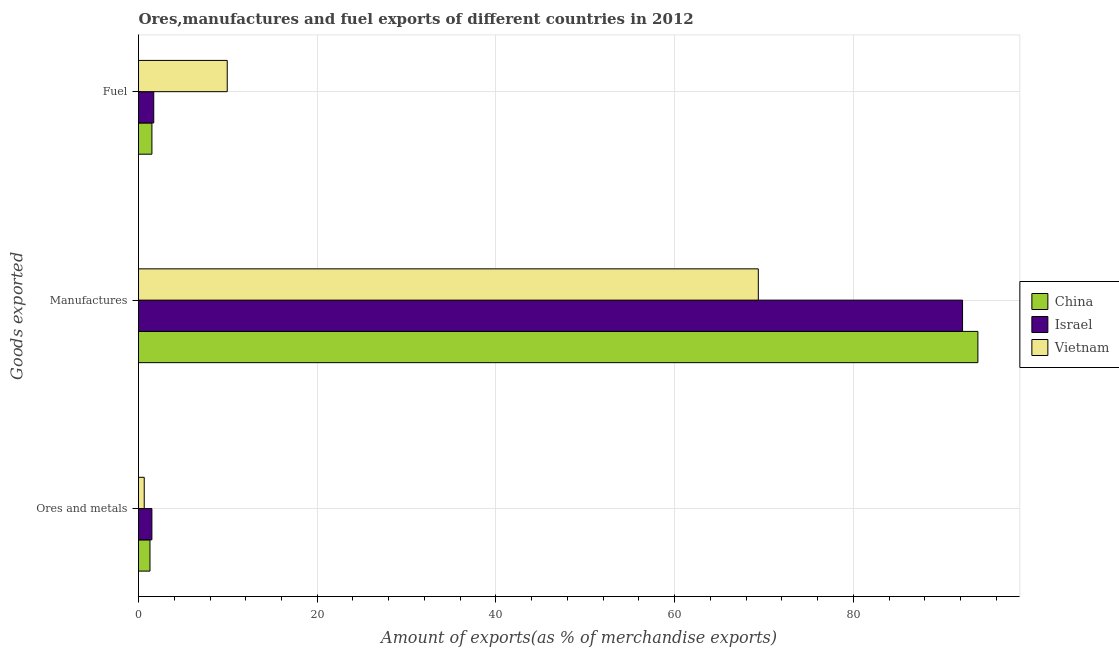Are the number of bars per tick equal to the number of legend labels?
Keep it short and to the point. Yes. How many bars are there on the 1st tick from the top?
Offer a terse response. 3. How many bars are there on the 3rd tick from the bottom?
Keep it short and to the point. 3. What is the label of the 3rd group of bars from the top?
Your answer should be very brief. Ores and metals. What is the percentage of fuel exports in Israel?
Provide a short and direct response. 1.7. Across all countries, what is the maximum percentage of manufactures exports?
Provide a succinct answer. 93.93. Across all countries, what is the minimum percentage of fuel exports?
Give a very brief answer. 1.5. In which country was the percentage of manufactures exports maximum?
Make the answer very short. China. What is the total percentage of fuel exports in the graph?
Provide a succinct answer. 13.14. What is the difference between the percentage of manufactures exports in Israel and that in Vietnam?
Give a very brief answer. 22.86. What is the difference between the percentage of fuel exports in Vietnam and the percentage of ores and metals exports in China?
Make the answer very short. 8.65. What is the average percentage of manufactures exports per country?
Offer a very short reply. 85.17. What is the difference between the percentage of ores and metals exports and percentage of manufactures exports in China?
Ensure brevity in your answer.  -92.65. In how many countries, is the percentage of ores and metals exports greater than 12 %?
Offer a terse response. 0. What is the ratio of the percentage of fuel exports in China to that in Israel?
Your response must be concise. 0.88. What is the difference between the highest and the second highest percentage of ores and metals exports?
Offer a terse response. 0.21. What is the difference between the highest and the lowest percentage of fuel exports?
Offer a terse response. 8.43. In how many countries, is the percentage of fuel exports greater than the average percentage of fuel exports taken over all countries?
Offer a terse response. 1. How many countries are there in the graph?
Your answer should be very brief. 3. Does the graph contain any zero values?
Provide a short and direct response. No. Where does the legend appear in the graph?
Offer a very short reply. Center right. How many legend labels are there?
Keep it short and to the point. 3. How are the legend labels stacked?
Your answer should be compact. Vertical. What is the title of the graph?
Offer a terse response. Ores,manufactures and fuel exports of different countries in 2012. Does "Turkmenistan" appear as one of the legend labels in the graph?
Ensure brevity in your answer.  No. What is the label or title of the X-axis?
Provide a succinct answer. Amount of exports(as % of merchandise exports). What is the label or title of the Y-axis?
Your response must be concise. Goods exported. What is the Amount of exports(as % of merchandise exports) in China in Ores and metals?
Ensure brevity in your answer.  1.28. What is the Amount of exports(as % of merchandise exports) of Israel in Ores and metals?
Your answer should be compact. 1.5. What is the Amount of exports(as % of merchandise exports) of Vietnam in Ores and metals?
Give a very brief answer. 0.64. What is the Amount of exports(as % of merchandise exports) of China in Manufactures?
Give a very brief answer. 93.93. What is the Amount of exports(as % of merchandise exports) of Israel in Manufactures?
Provide a succinct answer. 92.22. What is the Amount of exports(as % of merchandise exports) of Vietnam in Manufactures?
Ensure brevity in your answer.  69.36. What is the Amount of exports(as % of merchandise exports) in China in Fuel?
Offer a very short reply. 1.5. What is the Amount of exports(as % of merchandise exports) in Israel in Fuel?
Keep it short and to the point. 1.7. What is the Amount of exports(as % of merchandise exports) in Vietnam in Fuel?
Ensure brevity in your answer.  9.93. Across all Goods exported, what is the maximum Amount of exports(as % of merchandise exports) in China?
Ensure brevity in your answer.  93.93. Across all Goods exported, what is the maximum Amount of exports(as % of merchandise exports) of Israel?
Keep it short and to the point. 92.22. Across all Goods exported, what is the maximum Amount of exports(as % of merchandise exports) in Vietnam?
Make the answer very short. 69.36. Across all Goods exported, what is the minimum Amount of exports(as % of merchandise exports) of China?
Give a very brief answer. 1.28. Across all Goods exported, what is the minimum Amount of exports(as % of merchandise exports) in Israel?
Offer a very short reply. 1.5. Across all Goods exported, what is the minimum Amount of exports(as % of merchandise exports) of Vietnam?
Provide a succinct answer. 0.64. What is the total Amount of exports(as % of merchandise exports) of China in the graph?
Keep it short and to the point. 96.72. What is the total Amount of exports(as % of merchandise exports) of Israel in the graph?
Your answer should be compact. 95.42. What is the total Amount of exports(as % of merchandise exports) in Vietnam in the graph?
Your answer should be compact. 79.93. What is the difference between the Amount of exports(as % of merchandise exports) in China in Ores and metals and that in Manufactures?
Offer a terse response. -92.65. What is the difference between the Amount of exports(as % of merchandise exports) in Israel in Ores and metals and that in Manufactures?
Offer a terse response. -90.72. What is the difference between the Amount of exports(as % of merchandise exports) of Vietnam in Ores and metals and that in Manufactures?
Keep it short and to the point. -68.72. What is the difference between the Amount of exports(as % of merchandise exports) in China in Ores and metals and that in Fuel?
Give a very brief answer. -0.22. What is the difference between the Amount of exports(as % of merchandise exports) in Israel in Ores and metals and that in Fuel?
Offer a terse response. -0.21. What is the difference between the Amount of exports(as % of merchandise exports) of Vietnam in Ores and metals and that in Fuel?
Offer a terse response. -9.29. What is the difference between the Amount of exports(as % of merchandise exports) of China in Manufactures and that in Fuel?
Offer a terse response. 92.43. What is the difference between the Amount of exports(as % of merchandise exports) in Israel in Manufactures and that in Fuel?
Offer a terse response. 90.51. What is the difference between the Amount of exports(as % of merchandise exports) in Vietnam in Manufactures and that in Fuel?
Offer a terse response. 59.43. What is the difference between the Amount of exports(as % of merchandise exports) of China in Ores and metals and the Amount of exports(as % of merchandise exports) of Israel in Manufactures?
Ensure brevity in your answer.  -90.93. What is the difference between the Amount of exports(as % of merchandise exports) in China in Ores and metals and the Amount of exports(as % of merchandise exports) in Vietnam in Manufactures?
Provide a succinct answer. -68.08. What is the difference between the Amount of exports(as % of merchandise exports) in Israel in Ores and metals and the Amount of exports(as % of merchandise exports) in Vietnam in Manufactures?
Provide a short and direct response. -67.86. What is the difference between the Amount of exports(as % of merchandise exports) of China in Ores and metals and the Amount of exports(as % of merchandise exports) of Israel in Fuel?
Keep it short and to the point. -0.42. What is the difference between the Amount of exports(as % of merchandise exports) in China in Ores and metals and the Amount of exports(as % of merchandise exports) in Vietnam in Fuel?
Provide a succinct answer. -8.65. What is the difference between the Amount of exports(as % of merchandise exports) in Israel in Ores and metals and the Amount of exports(as % of merchandise exports) in Vietnam in Fuel?
Offer a very short reply. -8.43. What is the difference between the Amount of exports(as % of merchandise exports) in China in Manufactures and the Amount of exports(as % of merchandise exports) in Israel in Fuel?
Give a very brief answer. 92.23. What is the difference between the Amount of exports(as % of merchandise exports) in China in Manufactures and the Amount of exports(as % of merchandise exports) in Vietnam in Fuel?
Ensure brevity in your answer.  84. What is the difference between the Amount of exports(as % of merchandise exports) in Israel in Manufactures and the Amount of exports(as % of merchandise exports) in Vietnam in Fuel?
Keep it short and to the point. 82.29. What is the average Amount of exports(as % of merchandise exports) in China per Goods exported?
Ensure brevity in your answer.  32.24. What is the average Amount of exports(as % of merchandise exports) of Israel per Goods exported?
Offer a very short reply. 31.81. What is the average Amount of exports(as % of merchandise exports) of Vietnam per Goods exported?
Your answer should be compact. 26.64. What is the difference between the Amount of exports(as % of merchandise exports) of China and Amount of exports(as % of merchandise exports) of Israel in Ores and metals?
Your answer should be compact. -0.21. What is the difference between the Amount of exports(as % of merchandise exports) in China and Amount of exports(as % of merchandise exports) in Vietnam in Ores and metals?
Ensure brevity in your answer.  0.64. What is the difference between the Amount of exports(as % of merchandise exports) in Israel and Amount of exports(as % of merchandise exports) in Vietnam in Ores and metals?
Give a very brief answer. 0.86. What is the difference between the Amount of exports(as % of merchandise exports) in China and Amount of exports(as % of merchandise exports) in Israel in Manufactures?
Provide a succinct answer. 1.72. What is the difference between the Amount of exports(as % of merchandise exports) in China and Amount of exports(as % of merchandise exports) in Vietnam in Manufactures?
Give a very brief answer. 24.57. What is the difference between the Amount of exports(as % of merchandise exports) of Israel and Amount of exports(as % of merchandise exports) of Vietnam in Manufactures?
Your answer should be compact. 22.86. What is the difference between the Amount of exports(as % of merchandise exports) in China and Amount of exports(as % of merchandise exports) in Israel in Fuel?
Ensure brevity in your answer.  -0.2. What is the difference between the Amount of exports(as % of merchandise exports) of China and Amount of exports(as % of merchandise exports) of Vietnam in Fuel?
Your answer should be very brief. -8.43. What is the difference between the Amount of exports(as % of merchandise exports) in Israel and Amount of exports(as % of merchandise exports) in Vietnam in Fuel?
Give a very brief answer. -8.23. What is the ratio of the Amount of exports(as % of merchandise exports) of China in Ores and metals to that in Manufactures?
Provide a short and direct response. 0.01. What is the ratio of the Amount of exports(as % of merchandise exports) of Israel in Ores and metals to that in Manufactures?
Make the answer very short. 0.02. What is the ratio of the Amount of exports(as % of merchandise exports) of Vietnam in Ores and metals to that in Manufactures?
Offer a terse response. 0.01. What is the ratio of the Amount of exports(as % of merchandise exports) of China in Ores and metals to that in Fuel?
Provide a short and direct response. 0.86. What is the ratio of the Amount of exports(as % of merchandise exports) of Israel in Ores and metals to that in Fuel?
Make the answer very short. 0.88. What is the ratio of the Amount of exports(as % of merchandise exports) of Vietnam in Ores and metals to that in Fuel?
Your answer should be very brief. 0.06. What is the ratio of the Amount of exports(as % of merchandise exports) of China in Manufactures to that in Fuel?
Provide a succinct answer. 62.55. What is the ratio of the Amount of exports(as % of merchandise exports) in Israel in Manufactures to that in Fuel?
Provide a short and direct response. 54.09. What is the ratio of the Amount of exports(as % of merchandise exports) in Vietnam in Manufactures to that in Fuel?
Your response must be concise. 6.99. What is the difference between the highest and the second highest Amount of exports(as % of merchandise exports) of China?
Provide a short and direct response. 92.43. What is the difference between the highest and the second highest Amount of exports(as % of merchandise exports) of Israel?
Provide a succinct answer. 90.51. What is the difference between the highest and the second highest Amount of exports(as % of merchandise exports) of Vietnam?
Offer a terse response. 59.43. What is the difference between the highest and the lowest Amount of exports(as % of merchandise exports) in China?
Ensure brevity in your answer.  92.65. What is the difference between the highest and the lowest Amount of exports(as % of merchandise exports) in Israel?
Provide a short and direct response. 90.72. What is the difference between the highest and the lowest Amount of exports(as % of merchandise exports) of Vietnam?
Give a very brief answer. 68.72. 